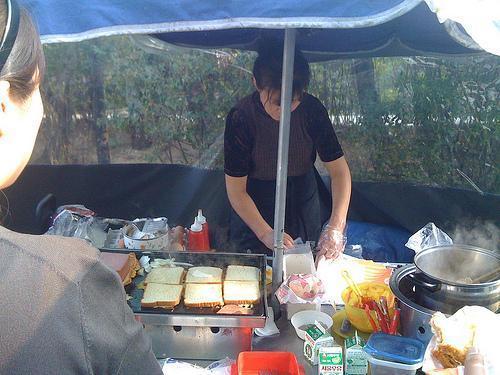How many people are in this photograph?
Give a very brief answer. 2. How many sandwiches are on the griddle?
Give a very brief answer. 6. How many bottles of catsup are there?
Give a very brief answer. 2. 